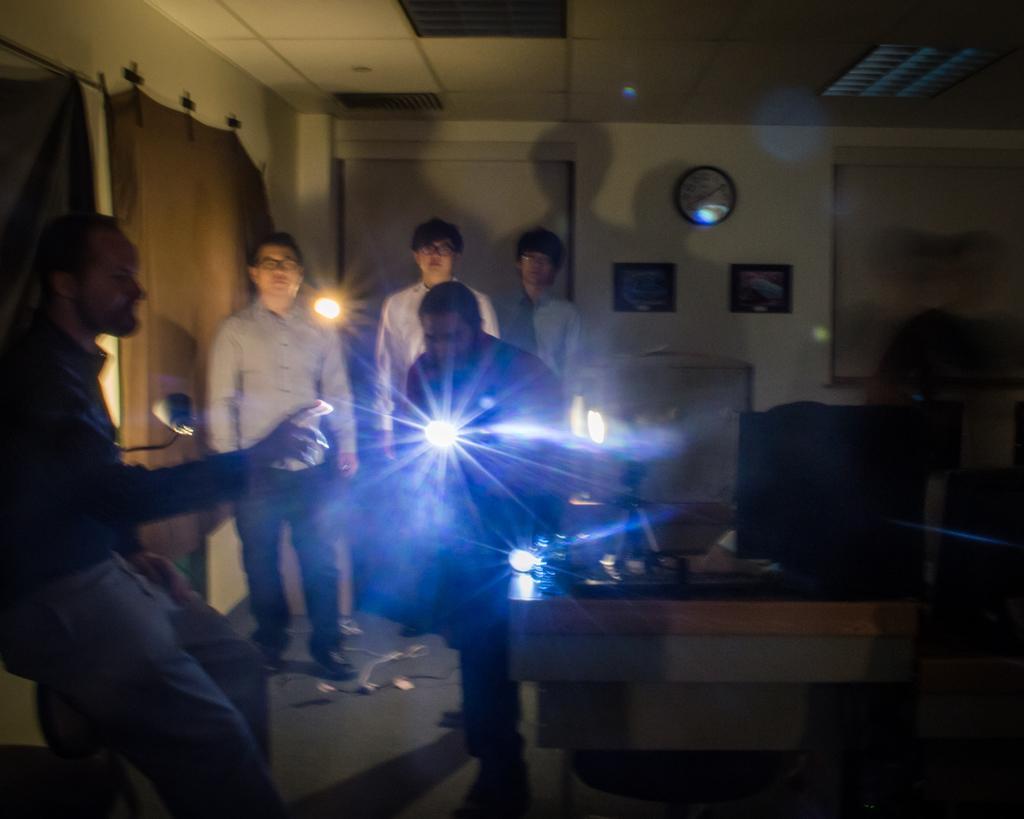Please provide a concise description of this image. In the picture I can see people standing on the floor. I can also see a table which has some objects on it. In the background I can see clock and some other objects attached to the wall. Here I can see lights and ceiling. 